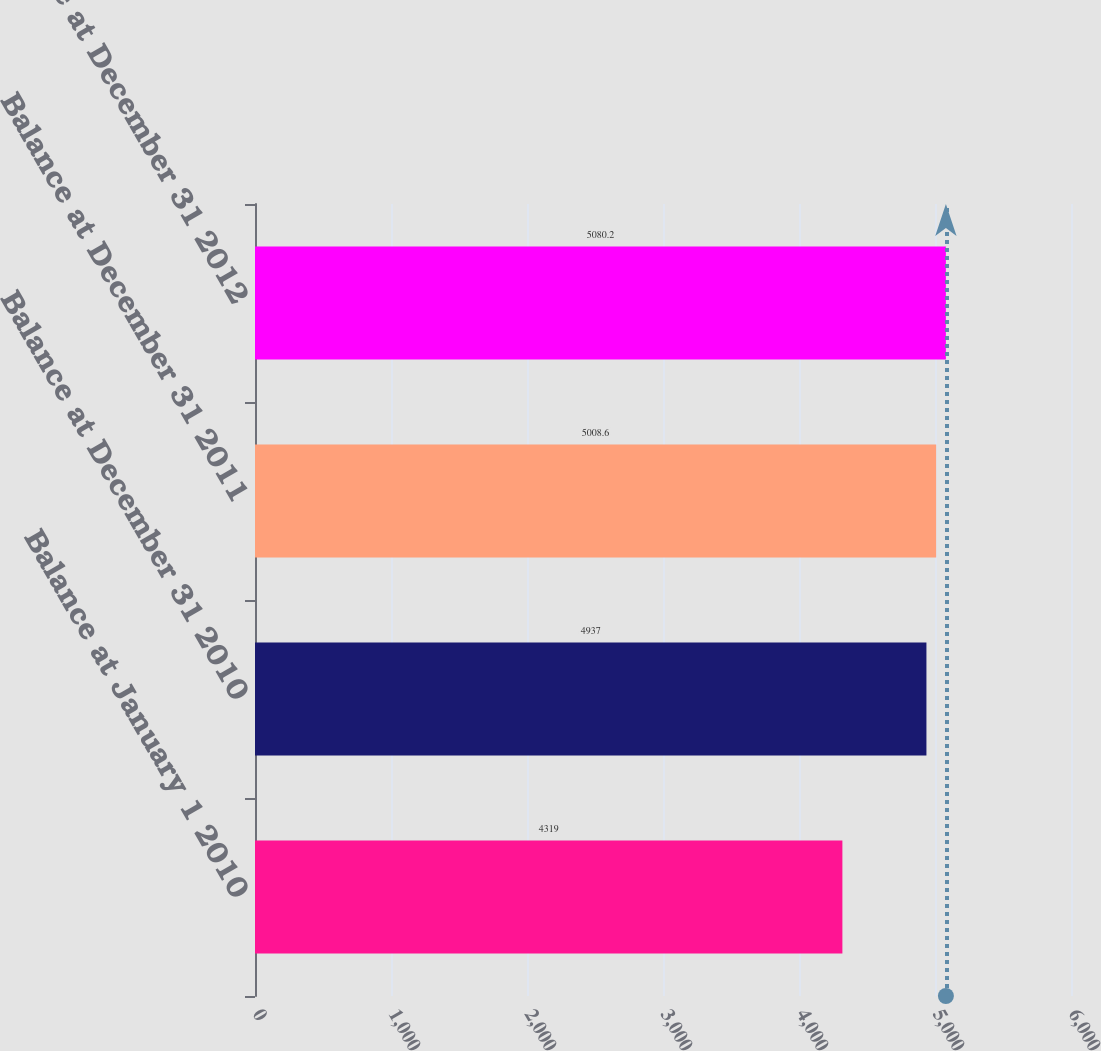<chart> <loc_0><loc_0><loc_500><loc_500><bar_chart><fcel>Balance at January 1 2010<fcel>Balance at December 31 2010<fcel>Balance at December 31 2011<fcel>Balance at December 31 2012<nl><fcel>4319<fcel>4937<fcel>5008.6<fcel>5080.2<nl></chart> 